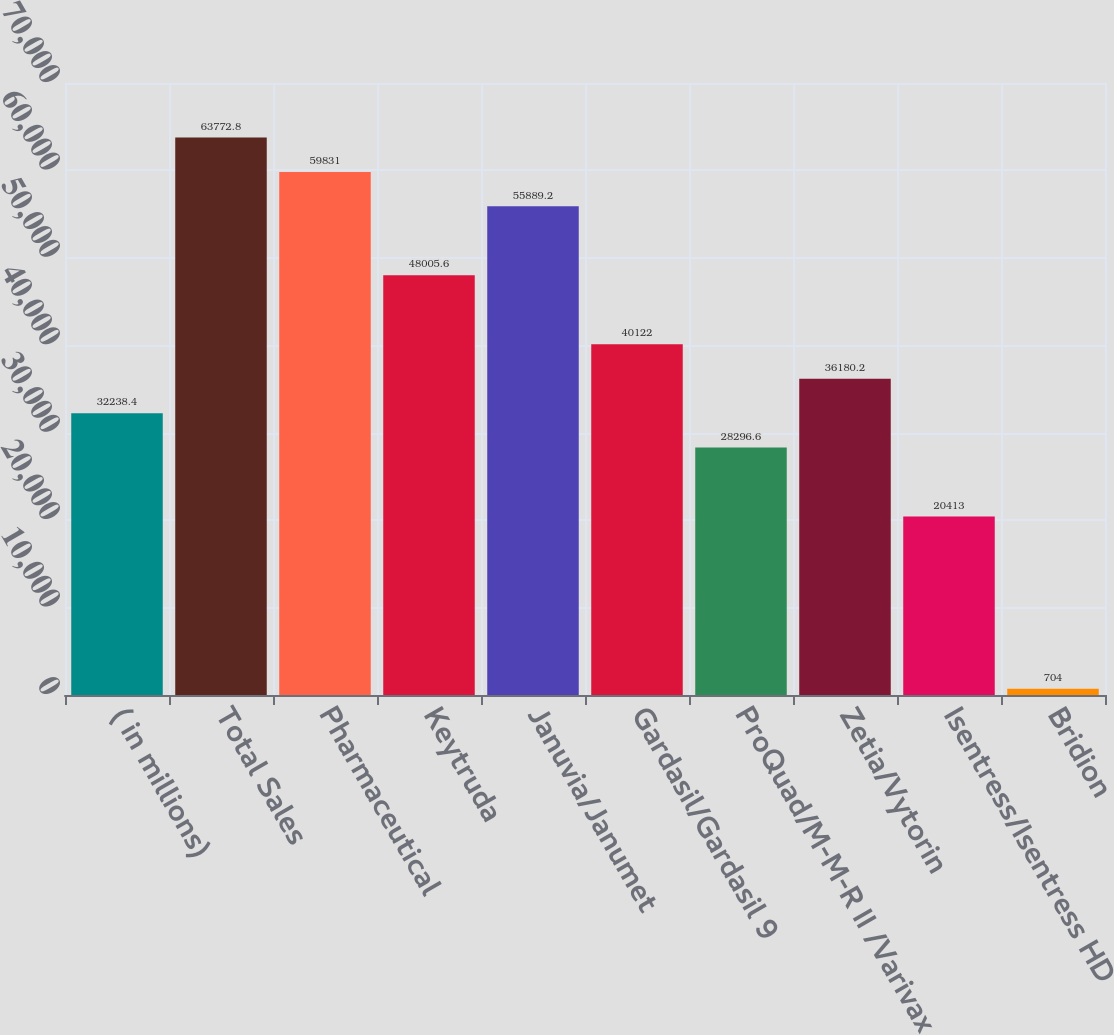<chart> <loc_0><loc_0><loc_500><loc_500><bar_chart><fcel>( in millions)<fcel>Total Sales<fcel>Pharmaceutical<fcel>Keytruda<fcel>Januvia/Janumet<fcel>Gardasil/Gardasil 9<fcel>ProQuad/M-M-R II /Varivax<fcel>Zetia/Vytorin<fcel>Isentress/Isentress HD<fcel>Bridion<nl><fcel>32238.4<fcel>63772.8<fcel>59831<fcel>48005.6<fcel>55889.2<fcel>40122<fcel>28296.6<fcel>36180.2<fcel>20413<fcel>704<nl></chart> 